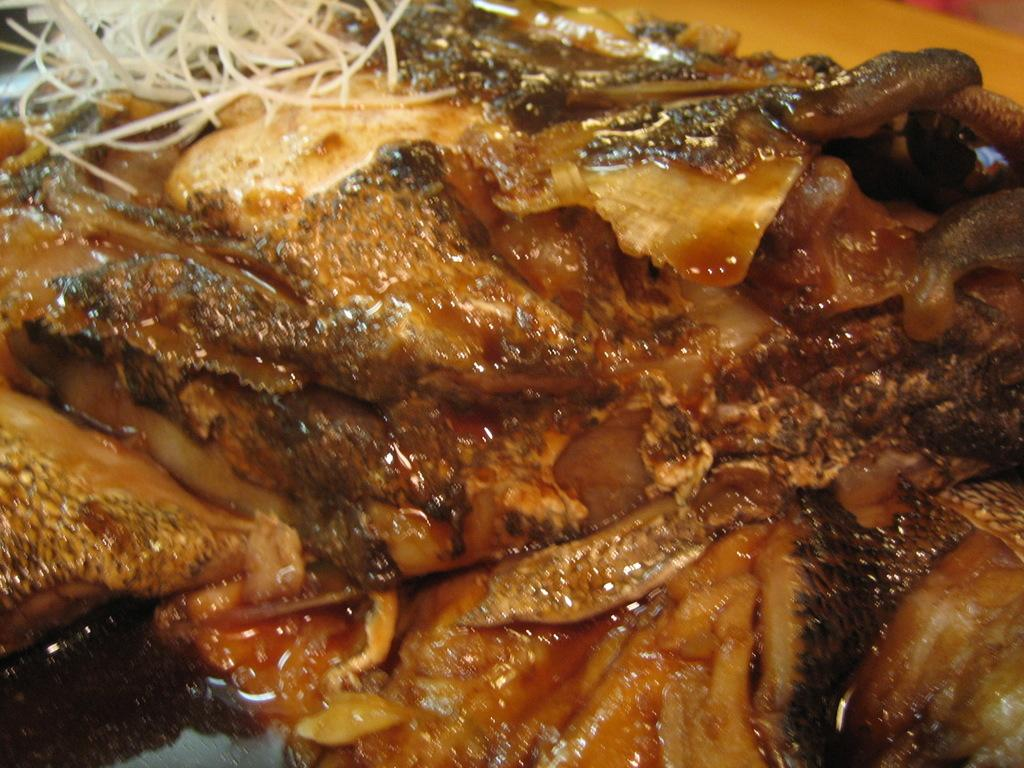What type of food is depicted in the image? There are fish pieces in the image. What is the fish pieces cooked in? The fish pieces are in oil. What other ingredients are visible in the image? There are onion pieces in the image. Where are the onion pieces located in relation to the fish pieces? The onion pieces are at the top. What can be seen in the top right corner of the image? There is a table visible in the top right corner of the image. What attempt did the mother make to write letters on the fish pieces? There is no mention of a mother or any attempt to write letters on the fish pieces in the image. 